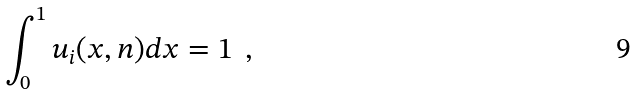<formula> <loc_0><loc_0><loc_500><loc_500>\int _ { 0 } ^ { 1 } u _ { i } ( x , n ) d x = 1 \ \, ,</formula> 